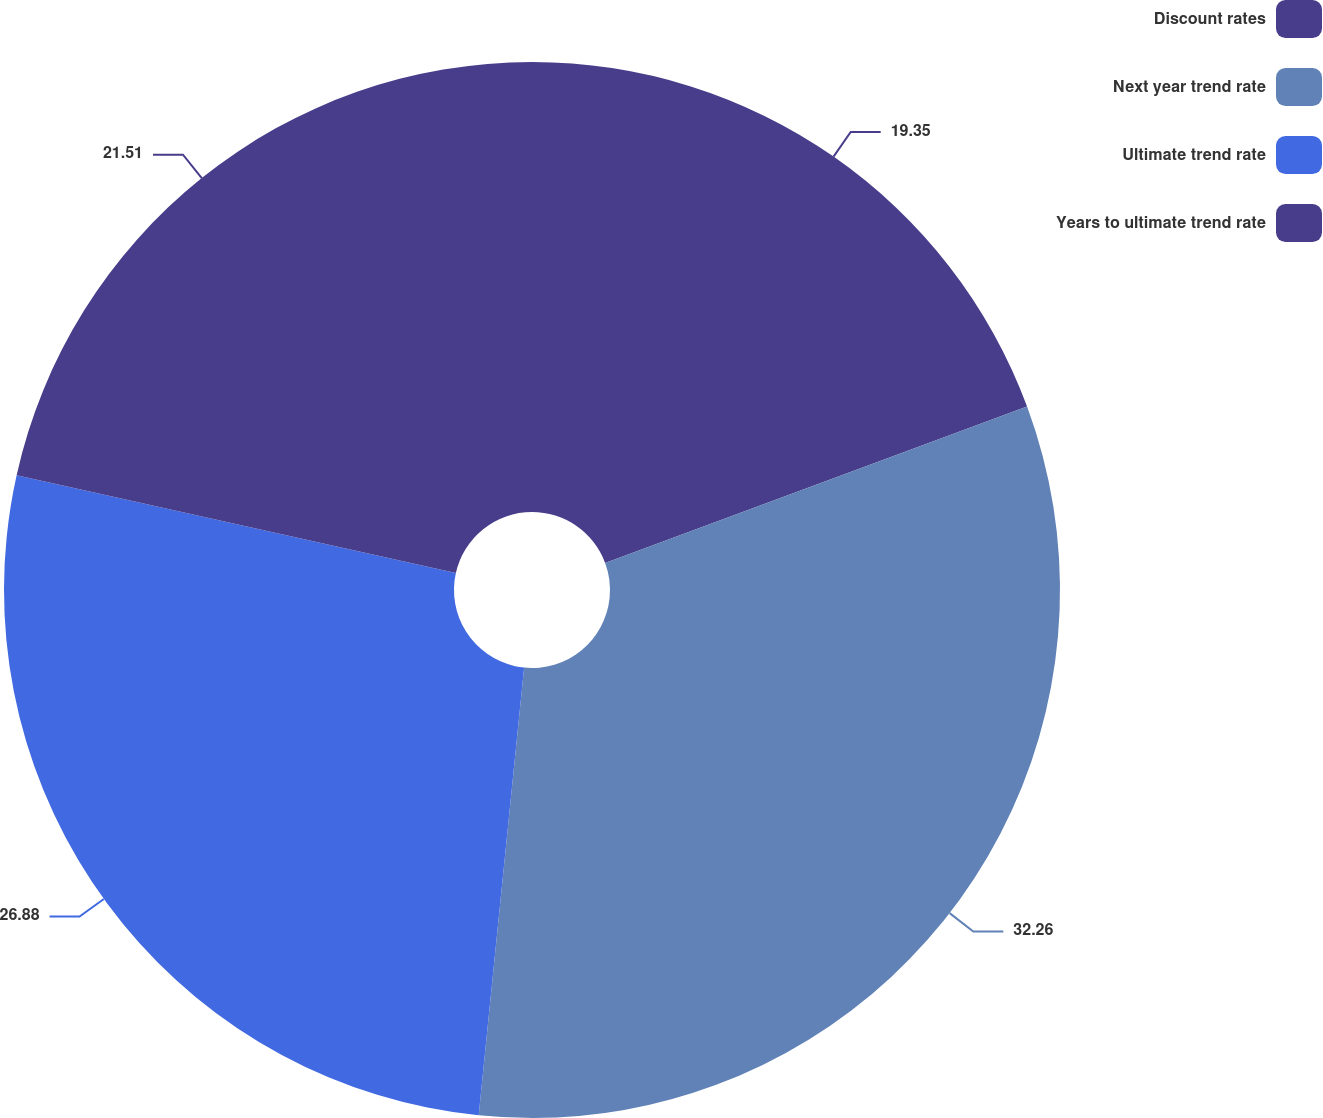Convert chart to OTSL. <chart><loc_0><loc_0><loc_500><loc_500><pie_chart><fcel>Discount rates<fcel>Next year trend rate<fcel>Ultimate trend rate<fcel>Years to ultimate trend rate<nl><fcel>19.35%<fcel>32.26%<fcel>26.88%<fcel>21.51%<nl></chart> 